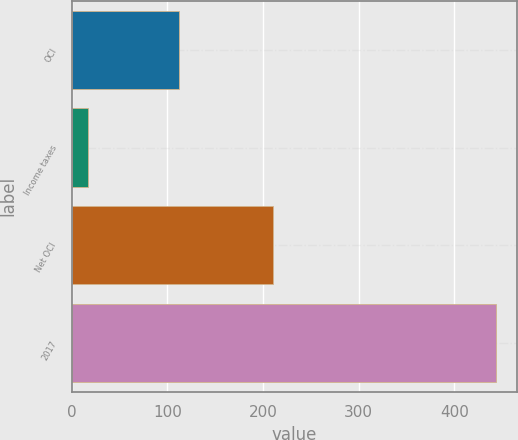<chart> <loc_0><loc_0><loc_500><loc_500><bar_chart><fcel>OCI<fcel>Income taxes<fcel>Net OCI<fcel>2017<nl><fcel>112<fcel>17<fcel>210<fcel>443<nl></chart> 